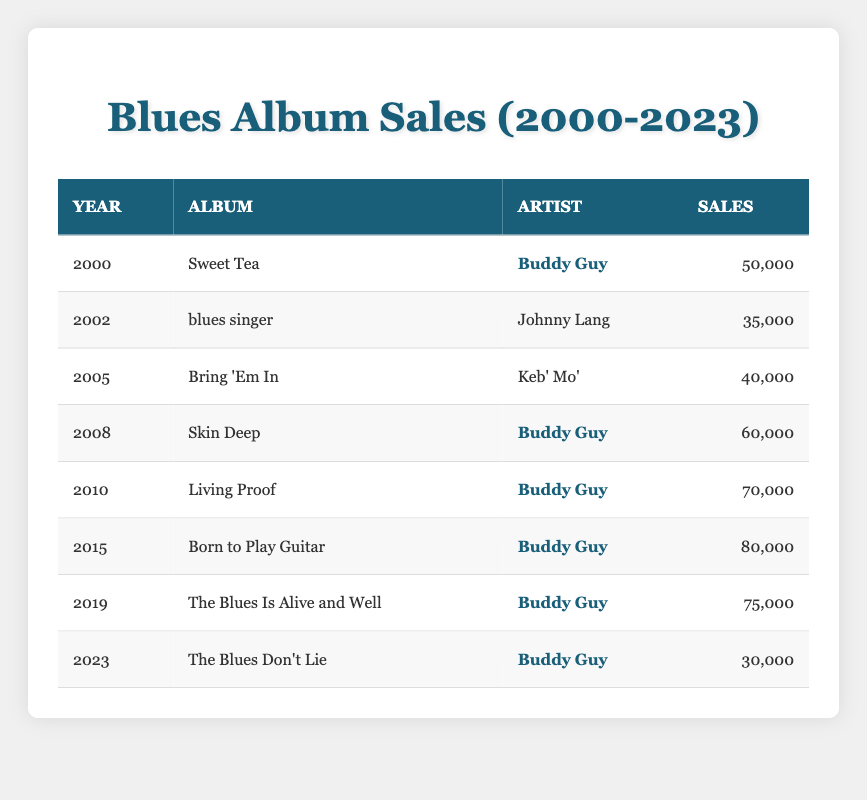What was Buddy Guy's best-selling album in the table? "Born to Play Guitar" had the highest sales figure of 80,000 in 2015, making it the best-selling album by Buddy Guy in this dataset.
Answer: Born to Play Guitar How many albums did Buddy Guy release in the years where sales exceeded 50,000? Buddy Guy's albums with sales over 50,000 are "Sweet Tea" (50,000 in 2000), "Skin Deep" (60,000 in 2008), "Living Proof" (70,000 in 2010), "Born to Play Guitar" (80,000 in 2015), and "The Blues Is Alive and Well" (75,000 in 2019). This totals 5 albums.
Answer: 5 What is the total sales for Buddy Guy's albums from 2000 to 2023? Adding Buddy Guy's album sales from the table gives us (50,000 + 60,000 + 70,000 + 80,000 + 75,000 + 30,000) = 365,000 total sales.
Answer: 365,000 Was the album "Skin Deep" released before "The Blues Is Alive and Well"? "Skin Deep" was released in 2008 and "The Blues Is Alive and Well" was released in 2019; since 2008 is before 2019, the statement is true.
Answer: Yes Which artist had a higher total sales across all their albums listed: Buddy Guy or Johnny Lang? Johnny Lang's album "blues singer" had 35,000 while Buddy Guy’s total sales are 365,000. Since 365,000 > 35,000, Buddy Guy had higher sales overall.
Answer: Buddy Guy What was the average sales figure for Buddy Guy's albums in the provided data? To find the average, sum the sales of Buddy Guy's albums (50,000 + 60,000 + 70,000 + 80,000 + 75,000 + 30,000 = 365,000). Then, divide by the number of albums (6). So, 365,000 / 6 = 60,833.33.
Answer: 60,833.33 How many years had sales below 40,000? The only album that had sales below 40,000 is "blues singer" by Johnny Lang, which sold 35,000 in 2002. Therefore, there is only 1 year with sales below 40,000.
Answer: 1 What was the sales decline from the highest-selling album to the lowest in the data? The highest-selling album is "Born to Play Guitar" with sales of 80,000, and the lowest is "The Blues Don’t Lie" with sales of 30,000. The decline is 80,000 - 30,000 = 50,000.
Answer: 50,000 Which album experienced a drop in sales compared to the previous album by Buddy Guy? Comparing the sales of his albums, “The Blues Is Alive and Well” (75,000) dropped compared to “Born to Play Guitar” (80,000). Therefore, "The Blues Is Alive and Well" experienced a decline in sales.
Answer: The Blues Is Alive and Well 